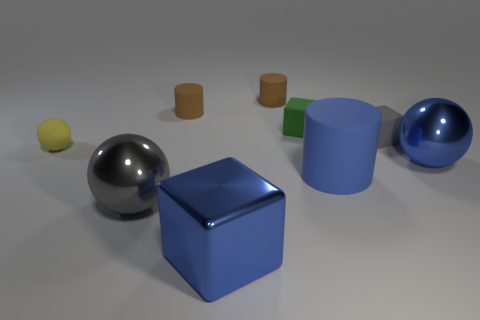Subtract all big shiny balls. How many balls are left? 1 Subtract all cubes. How many objects are left? 6 Add 1 cylinders. How many objects exist? 10 Subtract all blue cylinders. How many cylinders are left? 2 Subtract 2 cylinders. How many cylinders are left? 1 Subtract all red blocks. Subtract all gray spheres. How many blocks are left? 3 Subtract all blue cylinders. How many cyan spheres are left? 0 Subtract all big purple cylinders. Subtract all tiny matte objects. How many objects are left? 4 Add 7 big cubes. How many big cubes are left? 8 Add 5 yellow matte objects. How many yellow matte objects exist? 6 